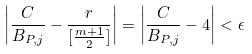<formula> <loc_0><loc_0><loc_500><loc_500>\left | \frac { C } { B _ { P , j } } - \frac { r } { [ \frac { m + 1 } { 2 } ] } \right | = \left | \frac { C } { B _ { P , j } } - 4 \right | < \epsilon</formula> 